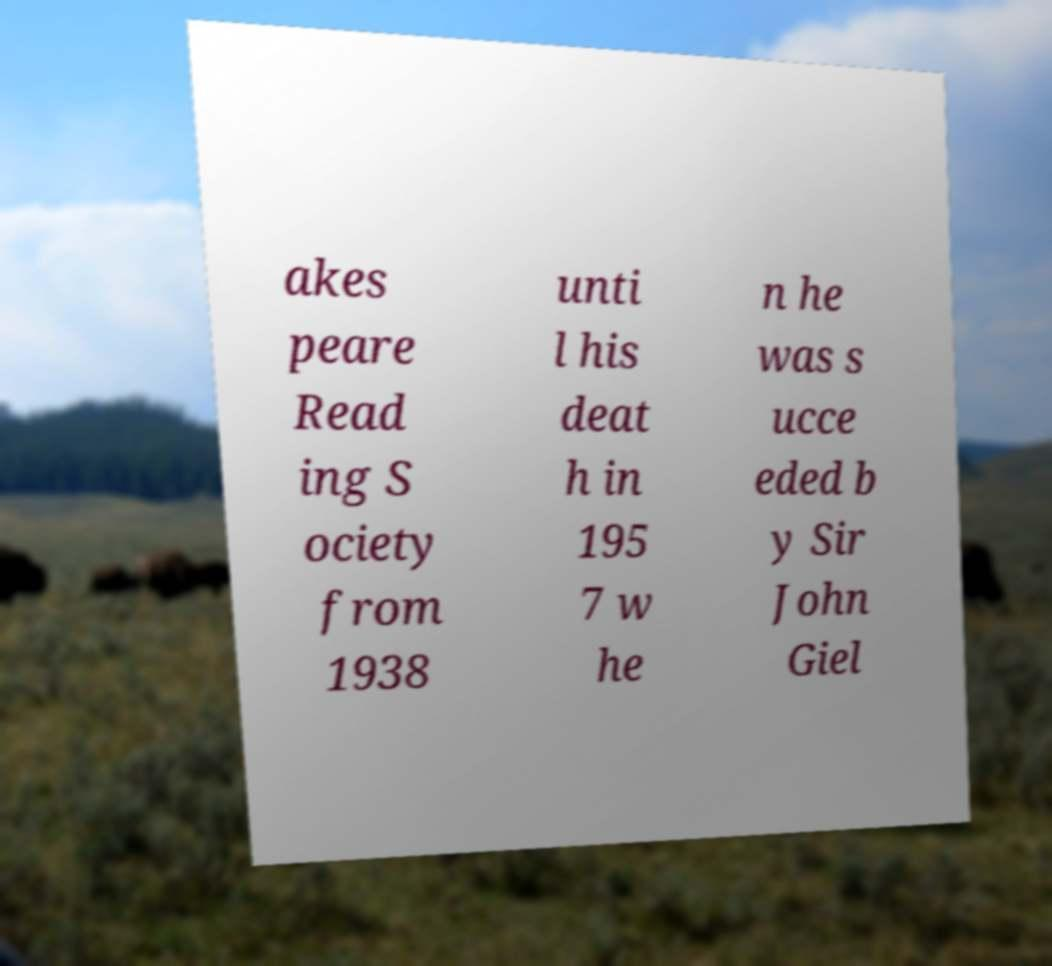Could you extract and type out the text from this image? akes peare Read ing S ociety from 1938 unti l his deat h in 195 7 w he n he was s ucce eded b y Sir John Giel 